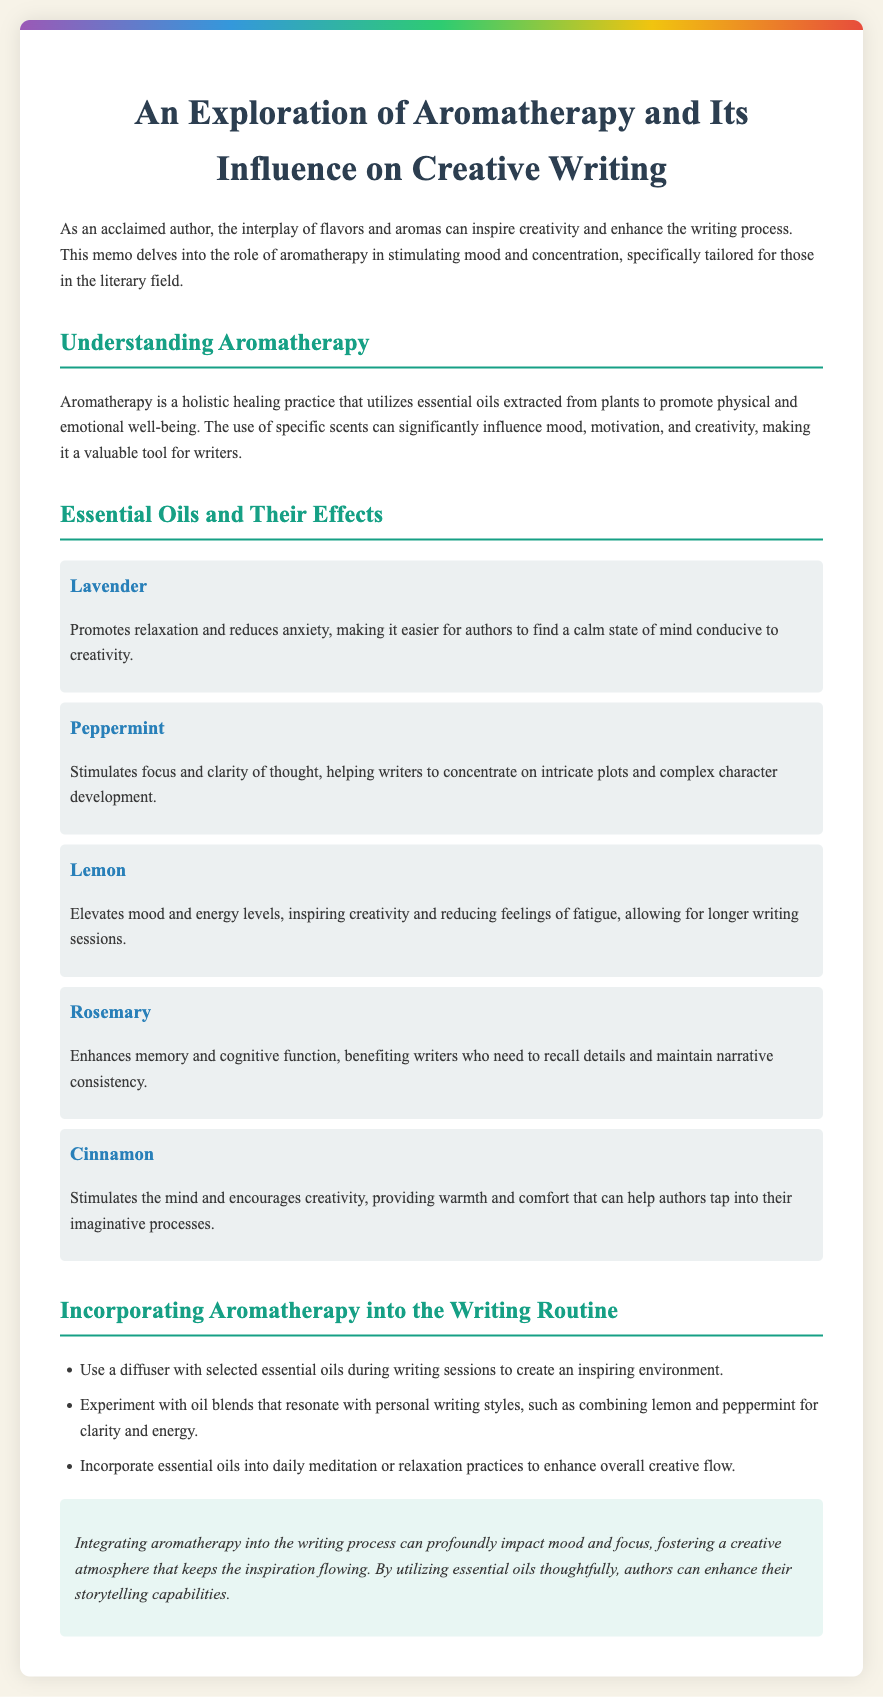What is the title of the memo? The title of the memo is prominently displayed at the top, indicating the main focus of the document.
Answer: An Exploration of Aromatherapy and Its Influence on Creative Writing What essential oil is associated with relaxation? The document lists essential oils and their effects, identifying lavender specifically for promoting relaxation.
Answer: Lavender Which essential oil stimulates focus? The memo mentions peppermint as an oil that enhances focus and clarity of thought.
Answer: Peppermint How many essential oils are mentioned in the document? The document lists a total of five essential oils, each with distinct effects on mood.
Answer: Five What effect does lemon have on mood? The effects of lemon are described as elevating mood and inspiring creativity, according to the memo.
Answer: Elevates mood Which essential oil enhances memory? Rosemary is specified in the memo as the oil that enhances memory and cognitive function.
Answer: Rosemary What is recommended for creating an inspiring environment during writing? The document suggests using a diffuser with selected essential oils to enhance the writing experience.
Answer: Use a diffuser What combination of oils is suggested for clarity and energy? The memo advises experimenting with a blend of lemon and peppermint for clarity and energy.
Answer: Lemon and peppermint What overall impact does integrating aromatherapy have on the writing process? The conclusion of the memo highlights the significant influence of aromatherapy on mood and focus, benefiting creativity.
Answer: Profound impact 